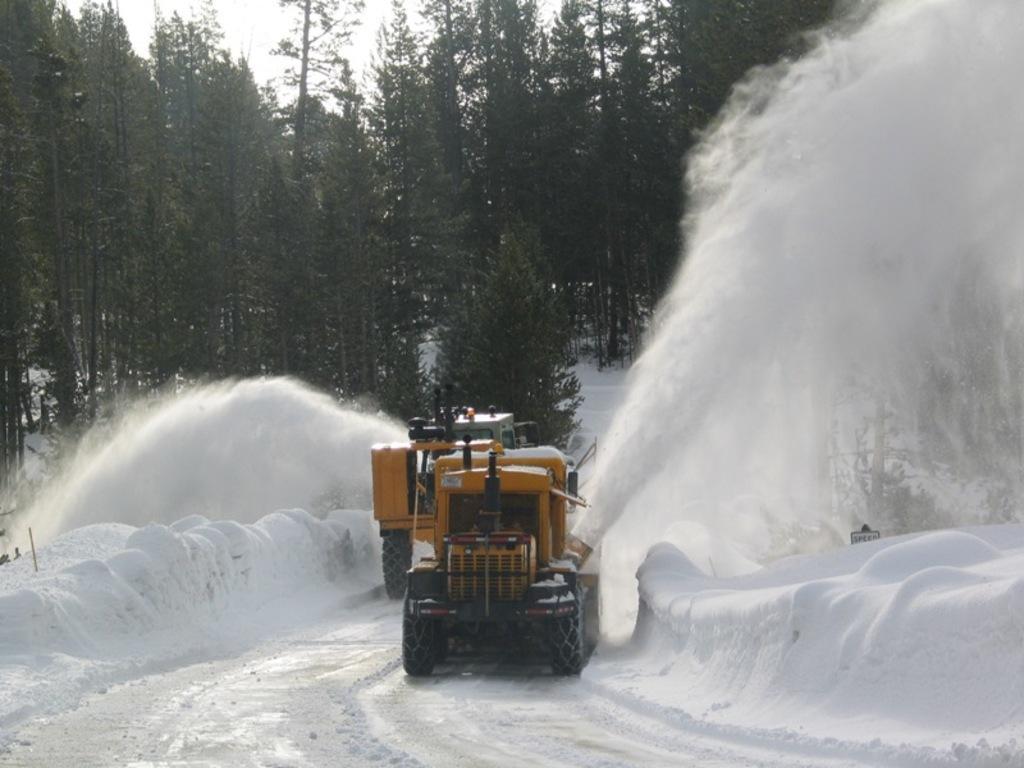In one or two sentences, can you explain what this image depicts? In this picture there are two vehicles on the road. On the left and on the right side of the image there is snow. At the back there are trees. At the top there is sky. 